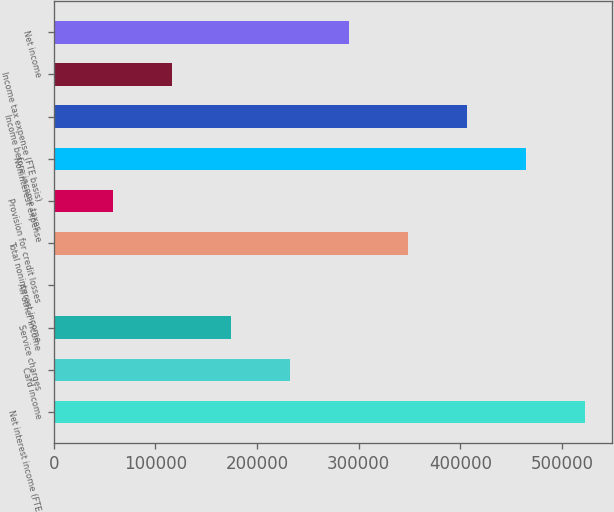Convert chart. <chart><loc_0><loc_0><loc_500><loc_500><bar_chart><fcel>Net interest income (FTE<fcel>Card income<fcel>Service charges<fcel>All other income<fcel>Total noninterest income<fcel>Provision for credit losses<fcel>Noninterest expense<fcel>Income before income taxes<fcel>Income tax expense (FTE basis)<fcel>Net income<nl><fcel>522713<fcel>232763<fcel>174773<fcel>803<fcel>348743<fcel>58793<fcel>464723<fcel>406733<fcel>116783<fcel>290753<nl></chart> 